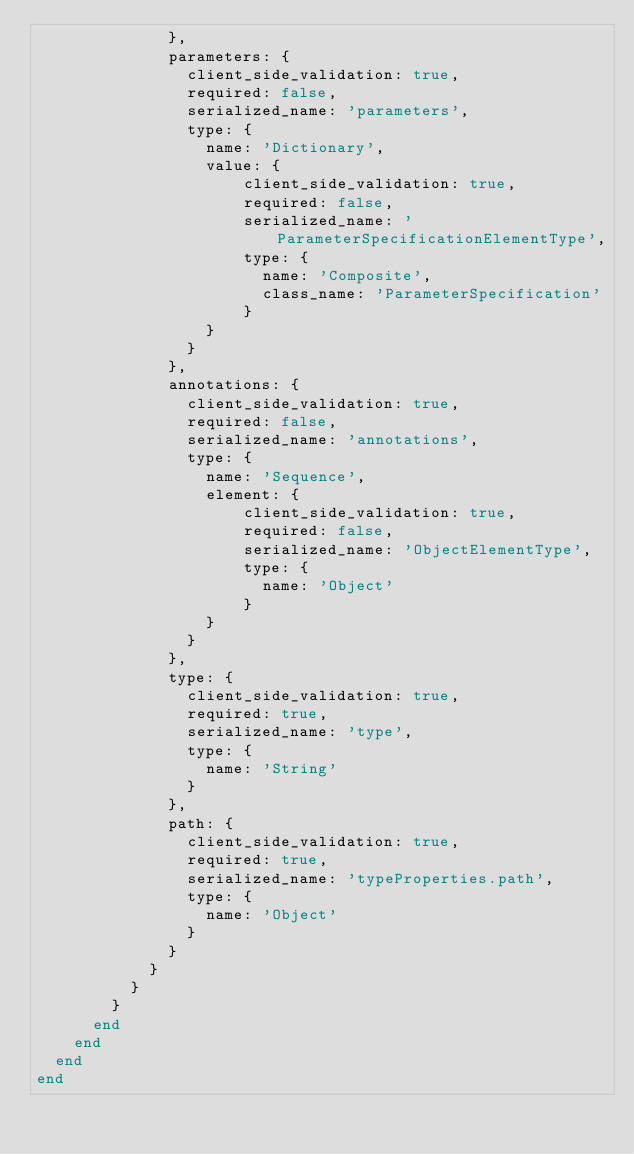Convert code to text. <code><loc_0><loc_0><loc_500><loc_500><_Ruby_>              },
              parameters: {
                client_side_validation: true,
                required: false,
                serialized_name: 'parameters',
                type: {
                  name: 'Dictionary',
                  value: {
                      client_side_validation: true,
                      required: false,
                      serialized_name: 'ParameterSpecificationElementType',
                      type: {
                        name: 'Composite',
                        class_name: 'ParameterSpecification'
                      }
                  }
                }
              },
              annotations: {
                client_side_validation: true,
                required: false,
                serialized_name: 'annotations',
                type: {
                  name: 'Sequence',
                  element: {
                      client_side_validation: true,
                      required: false,
                      serialized_name: 'ObjectElementType',
                      type: {
                        name: 'Object'
                      }
                  }
                }
              },
              type: {
                client_side_validation: true,
                required: true,
                serialized_name: 'type',
                type: {
                  name: 'String'
                }
              },
              path: {
                client_side_validation: true,
                required: true,
                serialized_name: 'typeProperties.path',
                type: {
                  name: 'Object'
                }
              }
            }
          }
        }
      end
    end
  end
end
</code> 